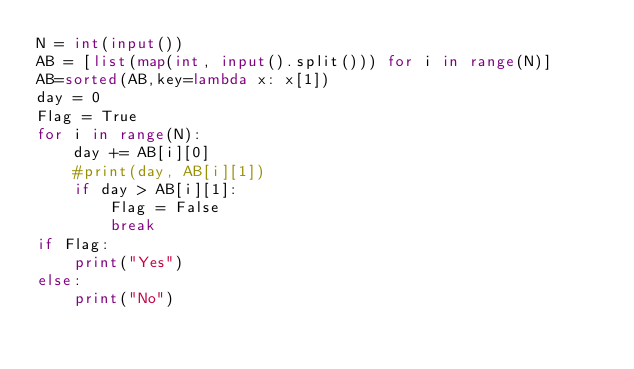<code> <loc_0><loc_0><loc_500><loc_500><_Python_>N = int(input())
AB = [list(map(int, input().split())) for i in range(N)]
AB=sorted(AB,key=lambda x: x[1])
day = 0
Flag = True
for i in range(N):
    day += AB[i][0]
    #print(day, AB[i][1])
    if day > AB[i][1]:
        Flag = False
        break
if Flag:
    print("Yes")
else:
    print("No")</code> 